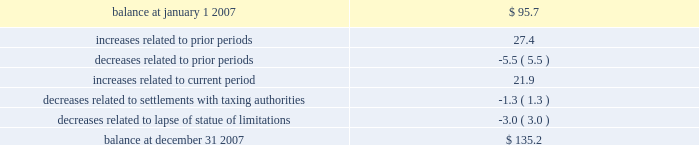In september 2007 , we reached a settlement with the united states department of justice in an ongoing investigation into financial relationships between major orthopaedic manufacturers and consulting orthopaedic surgeons .
Under the terms of the settlement , we paid a civil settlement amount of $ 169.5 million and we recorded an expense in that amount .
No tax benefit has been recorded related to the settlement expense due to the uncertainty as to the tax treatment .
We intend to pursue resolution of this uncertainty with taxing authorities , but are unable to ascertain the outcome or timing for such resolution at this time .
For more information regarding the settlement , see note 15 .
In june 2006 , the financial accounting standards board ( fasb ) issued interpretation no .
48 , accounting for uncertainty in income taxes 2013 an interpretation of fasb statement no .
109 , accounting for income taxes ( fin 48 ) .
Fin 48 addresses the determination of whether tax benefits claimed or expected to be claimed on a tax return should be recorded in the financial statements .
Under fin 48 , we may recognize the tax benefit from an uncertain tax position only if it is more likely than not that the tax position will be sustained on examination by the taxing authorities , based on the technical merits of the position .
The tax benefits recognized in the financial statements from such a position should be measured based on the largest benefit that has a greater than fifty percent likelihood of being realized upon ultimate settlement .
Fin 48 also provides guidance on derecognition , classification , interest and penalties on income taxes , accounting in interim periods and requires increased disclosures .
We adopted fin 48 on january 1 , 2007 .
Prior to the adoption of fin 48 we had a long term tax liability for expected settlement of various federal , state and foreign income tax liabilities that was reflected net of the corollary tax impact of these expected settlements of $ 102.1 million , as well as a separate accrued interest liability of $ 1.7 million .
As a result of the adoption of fin 48 , we are required to present the different components of such liability on a gross basis versus the historical net presentation .
The adoption resulted in the financial statement liability for unrecognized tax benefits decreasing by $ 6.4 million as of january 1 , 2007 .
The adoption resulted in this decrease in the liability as well as a reduction to retained earnings of $ 4.8 million , a reduction in goodwill of $ 61.4 million , the establishment of a tax receivable of $ 58.2 million , which was recorded in other current and non-current assets on our consolidated balance sheet , and an increase in an interest/penalty payable of $ 7.9 million , all as of january 1 , 2007 .
Therefore , after the adoption of fin 48 , the amount of unrecognized tax benefits is $ 95.7 million as of january 1 , 2007 , of which $ 28.6 million would impact our effective tax rate , if recognized .
The amount of unrecognized tax benefits is $ 135.2 million as of december 31 , 2007 .
Of this amount , $ 41.0 million would impact our effective tax rate , if recognized .
A reconciliation of the beginning and ending amounts of unrecognized tax benefits is as follows ( in millions ) : .
We recognize accrued interest and penalties related to unrecognized tax benefits in income tax expense in the consolidated statements of earnings , which is consistent with the recognition of these items in prior reporting periods .
As of january 1 , 2007 , we recorded a liability of $ 9.6 million for accrued interest and penalties , of which $ 7.5 million would impact our effective tax rate , if recognized .
The amount of this liability is $ 19.6 million as of december 31 , 2007 .
Of this amount , $ 14.7 million would impact our effective tax rate , if recognized .
We expect that the amount of tax liability for unrecognized tax benefits will change in the next twelve months ; however , we do not expect these changes will have a significant impact on our results of operations or financial position .
The u.s .
Federal statute of limitations remains open for the year 2003 and onward with years 2003 and 2004 currently under examination by the irs .
It is reasonably possible that a resolution with the irs for the years 2003 through 2004 will be reached within the next twelve months , but we do not anticipate this would result in any material impact on our financial position .
In addition , for the 1999 tax year of centerpulse , which we acquired in october 2003 , one issue remains in dispute .
The resolution of this issue would not impact our effective tax rate , as it would be recorded as an adjustment to goodwill .
State income tax returns are generally subject to examination for a period of 3 to 5 years after filing of the respective return .
The state impact of any federal changes remains subject to examination by various states for a period of up to one year after formal notification to the states .
We have various state income tax returns in the process of examination , administrative appeals or litigation .
It is reasonably possible that such matters will be resolved in the next twelve months , but we do not anticipate that the resolution of these matters would result in any material impact on our results of operations or financial position .
Foreign jurisdictions have statutes of limitations generally ranging from 3 to 5 years .
Years still open to examination by foreign tax authorities in major jurisdictions include australia ( 2003 onward ) , canada ( 1999 onward ) , france ( 2005 onward ) , germany ( 2005 onward ) , italy ( 2003 onward ) , japan ( 2001 onward ) , puerto rico ( 2005 onward ) , singapore ( 2003 onward ) , switzerland ( 2004 onward ) , and the united kingdom ( 2005 onward ) .
Z i m m e r h o l d i n g s , i n c .
2 0 0 7 f o r m 1 0 - k a n n u a l r e p o r t notes to consolidated financial statements ( continued ) .
What percent did the balance increase in 2007? 
Rationale: makes more sense to do question 2 before question 1
Computations: ((135.2 / 95.7) - 1)
Answer: 0.41275. 